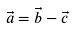<formula> <loc_0><loc_0><loc_500><loc_500>\vec { a } = \vec { b } - \vec { c }</formula> 